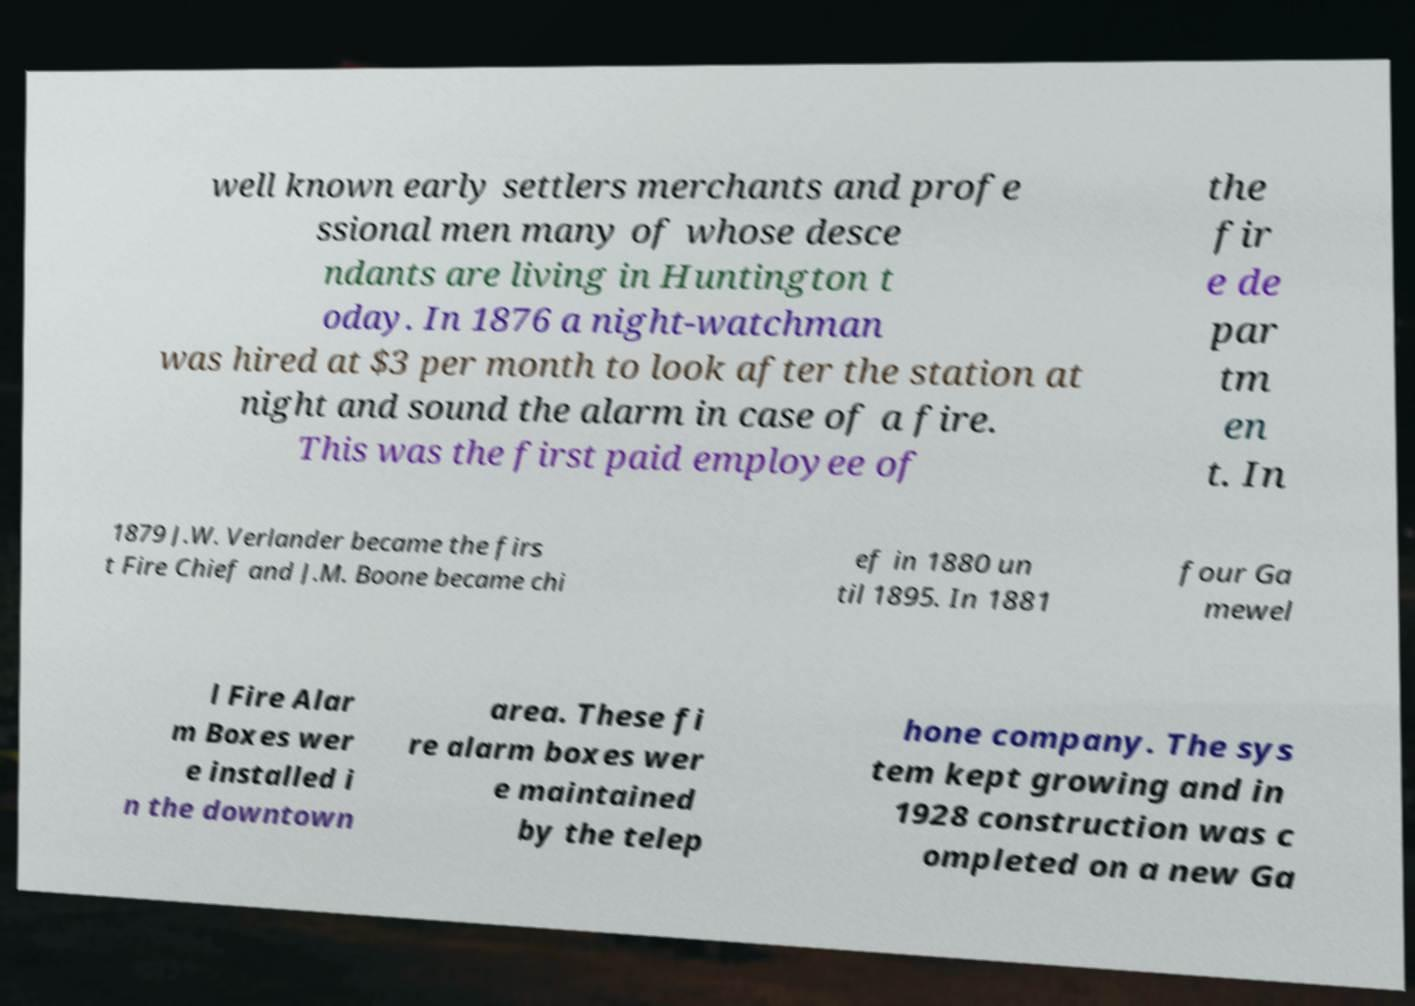There's text embedded in this image that I need extracted. Can you transcribe it verbatim? well known early settlers merchants and profe ssional men many of whose desce ndants are living in Huntington t oday. In 1876 a night-watchman was hired at $3 per month to look after the station at night and sound the alarm in case of a fire. This was the first paid employee of the fir e de par tm en t. In 1879 J.W. Verlander became the firs t Fire Chief and J.M. Boone became chi ef in 1880 un til 1895. In 1881 four Ga mewel l Fire Alar m Boxes wer e installed i n the downtown area. These fi re alarm boxes wer e maintained by the telep hone company. The sys tem kept growing and in 1928 construction was c ompleted on a new Ga 